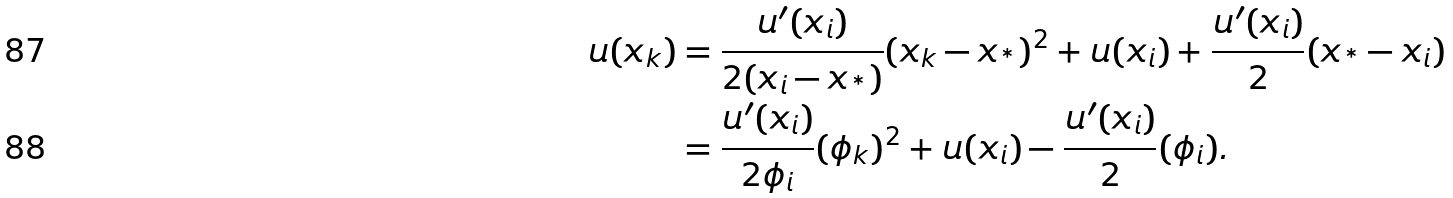Convert formula to latex. <formula><loc_0><loc_0><loc_500><loc_500>u ( x _ { k } ) & = \frac { u ^ { \prime } ( x _ { i } ) } { 2 ( x _ { i } - x _ { ^ { * } } ) } ( x _ { k } - x _ { ^ { * } } ) ^ { 2 } + u ( x _ { i } ) + \frac { u ^ { \prime } ( x _ { i } ) } { 2 } ( x _ { ^ { * } } - x _ { i } ) \\ & = \frac { u ^ { \prime } ( x _ { i } ) } { 2 \phi _ { i } } ( \phi _ { k } ) ^ { 2 } + u ( x _ { i } ) - \frac { u ^ { \prime } ( x _ { i } ) } { 2 } ( \phi _ { i } ) .</formula> 